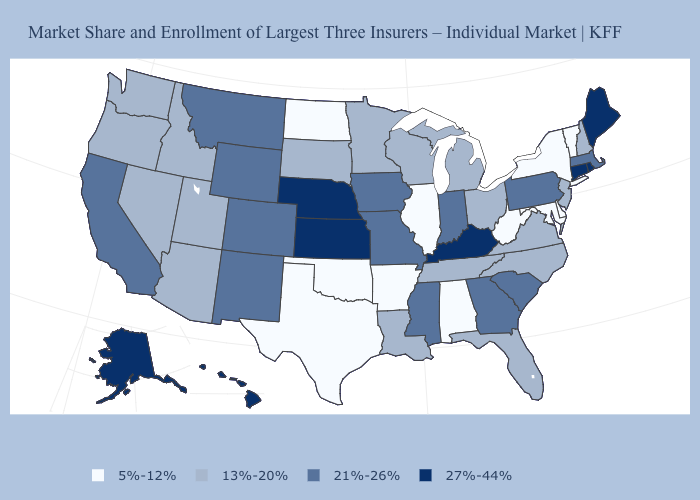What is the value of West Virginia?
Concise answer only. 5%-12%. Name the states that have a value in the range 5%-12%?
Give a very brief answer. Alabama, Arkansas, Delaware, Illinois, Maryland, New York, North Dakota, Oklahoma, Texas, Vermont, West Virginia. Does Nebraska have the highest value in the MidWest?
Keep it brief. Yes. How many symbols are there in the legend?
Give a very brief answer. 4. What is the value of Washington?
Concise answer only. 13%-20%. Among the states that border Maryland , which have the lowest value?
Keep it brief. Delaware, West Virginia. What is the lowest value in the MidWest?
Quick response, please. 5%-12%. Does Vermont have the lowest value in the USA?
Quick response, please. Yes. What is the lowest value in states that border Minnesota?
Write a very short answer. 5%-12%. What is the lowest value in the South?
Answer briefly. 5%-12%. Does Alaska have a higher value than Montana?
Concise answer only. Yes. Which states have the highest value in the USA?
Quick response, please. Alaska, Connecticut, Hawaii, Kansas, Kentucky, Maine, Nebraska, Rhode Island. Does Rhode Island have the highest value in the Northeast?
Give a very brief answer. Yes. What is the value of Delaware?
Write a very short answer. 5%-12%. 